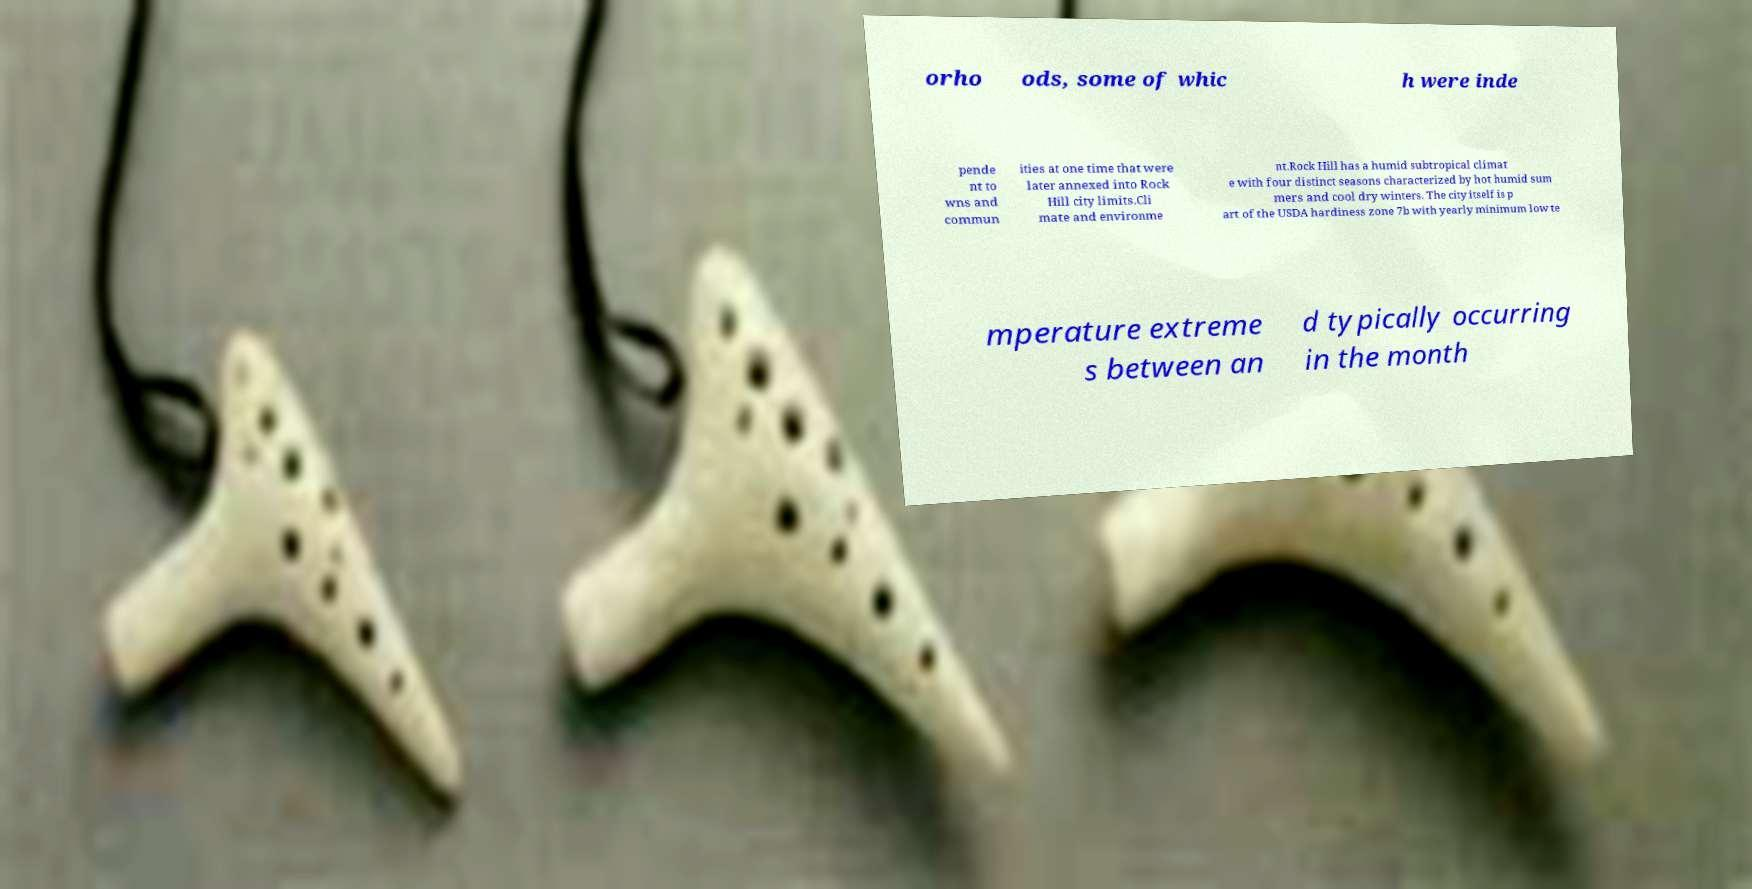Can you accurately transcribe the text from the provided image for me? orho ods, some of whic h were inde pende nt to wns and commun ities at one time that were later annexed into Rock Hill city limits.Cli mate and environme nt.Rock Hill has a humid subtropical climat e with four distinct seasons characterized by hot humid sum mers and cool dry winters. The city itself is p art of the USDA hardiness zone 7b with yearly minimum low te mperature extreme s between an d typically occurring in the month 